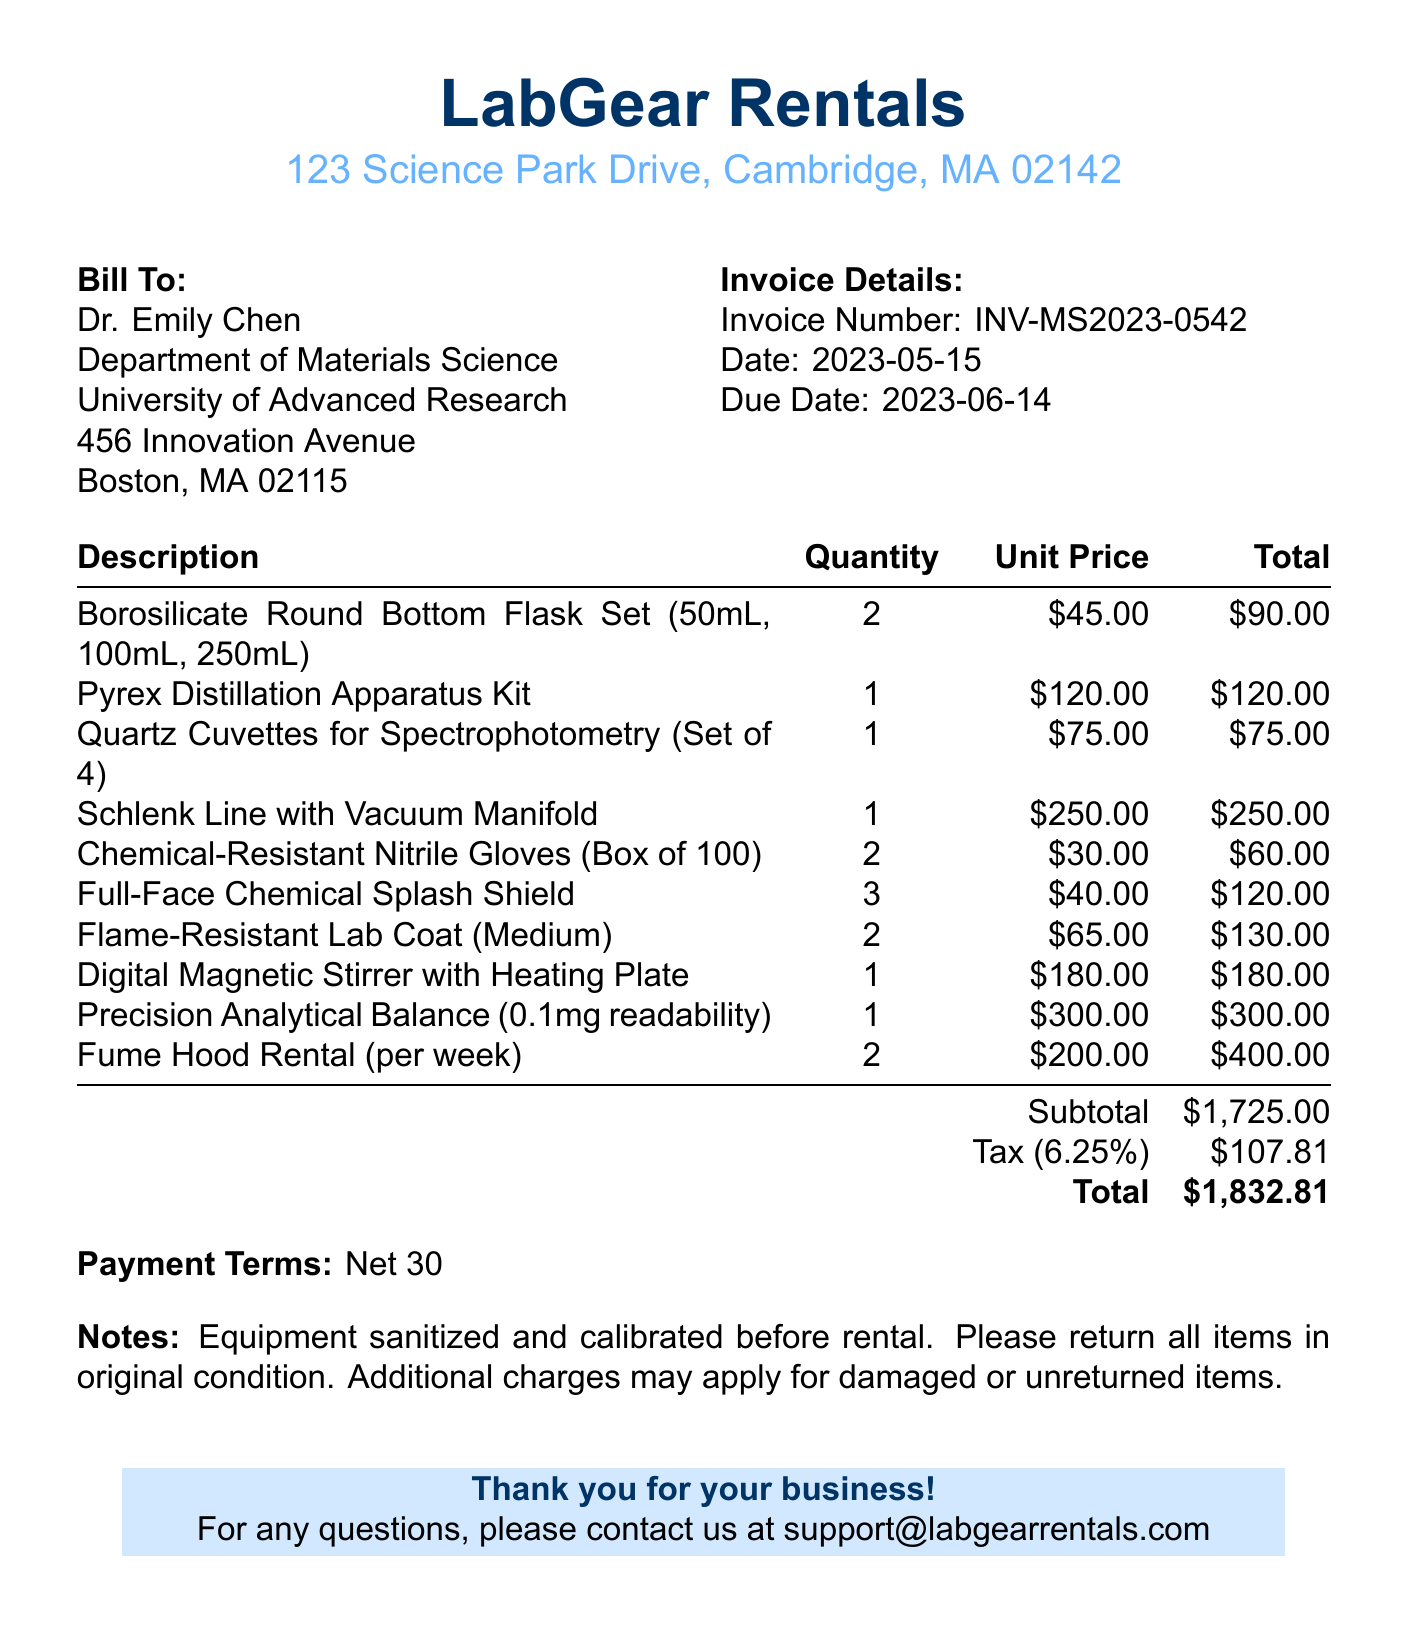What is the invoice number? The invoice number is found in the header section of the document.
Answer: INV-MS2023-0542 What is the due date for the invoice? The due date is indicated in the invoice details section.
Answer: 2023-06-14 Who is the customer? The customer name appears prominently in the "Bill To" section of the document.
Answer: Dr. Emily Chen How many Full-Face Chemical Splash Shields were rented? This information is found in the itemized list of rented equipment.
Answer: 3 What is the subtotal amount before tax? The subtotal is the total of all items listed before any tax is applied.
Answer: $1,725.00 What is the tax rate applied on the invoice? The tax rate is specified in the financial summary section of the invoice.
Answer: 6.25% What is the total amount due? The total amount is the final figure calculated in the invoice, including tax.
Answer: $1,832.81 How many items are listed in the invoice? The total count of items can be calculated from the itemized list provided in the document.
Answer: 10 What payment terms are specified on the invoice? The payment terms are stated near the end of the invoice document.
Answer: Net 30 